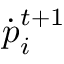<formula> <loc_0><loc_0><loc_500><loc_500>{ \dot { p } } _ { i } ^ { t + 1 }</formula> 